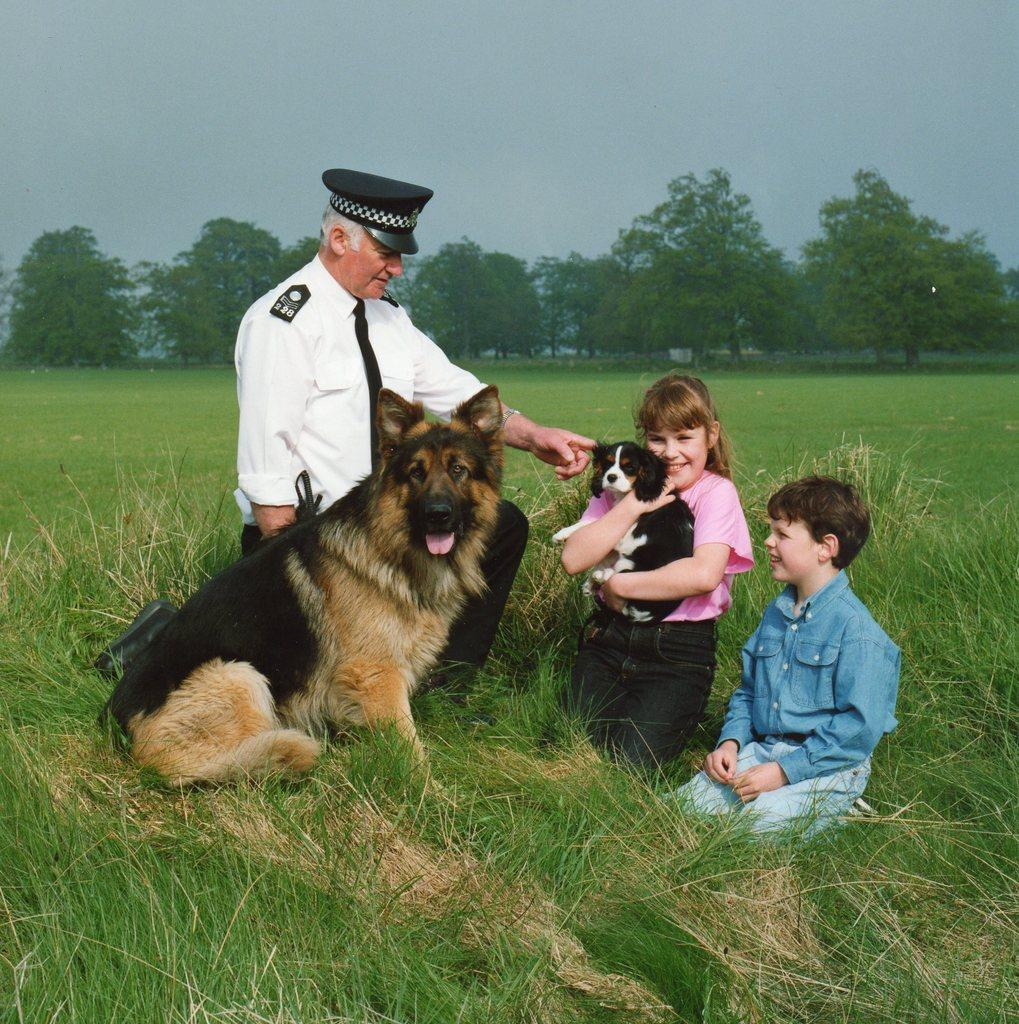What is the setting of the image? The image is set in a field. What type of vegetation can be seen in the field? There are trees and grass in the field. How many people are in the image? There are three people in the image. What other living creatures are present in the image? There are two dogs in the image. Where are the people and dogs located in the field? The people and dogs are sitting on the grass. What type of comfort can be seen in the image? There is no specific comfort item visible in the image. How many robins are present in the image? There are no robins present in the image; it features people and dogs sitting on the grass in a field. 